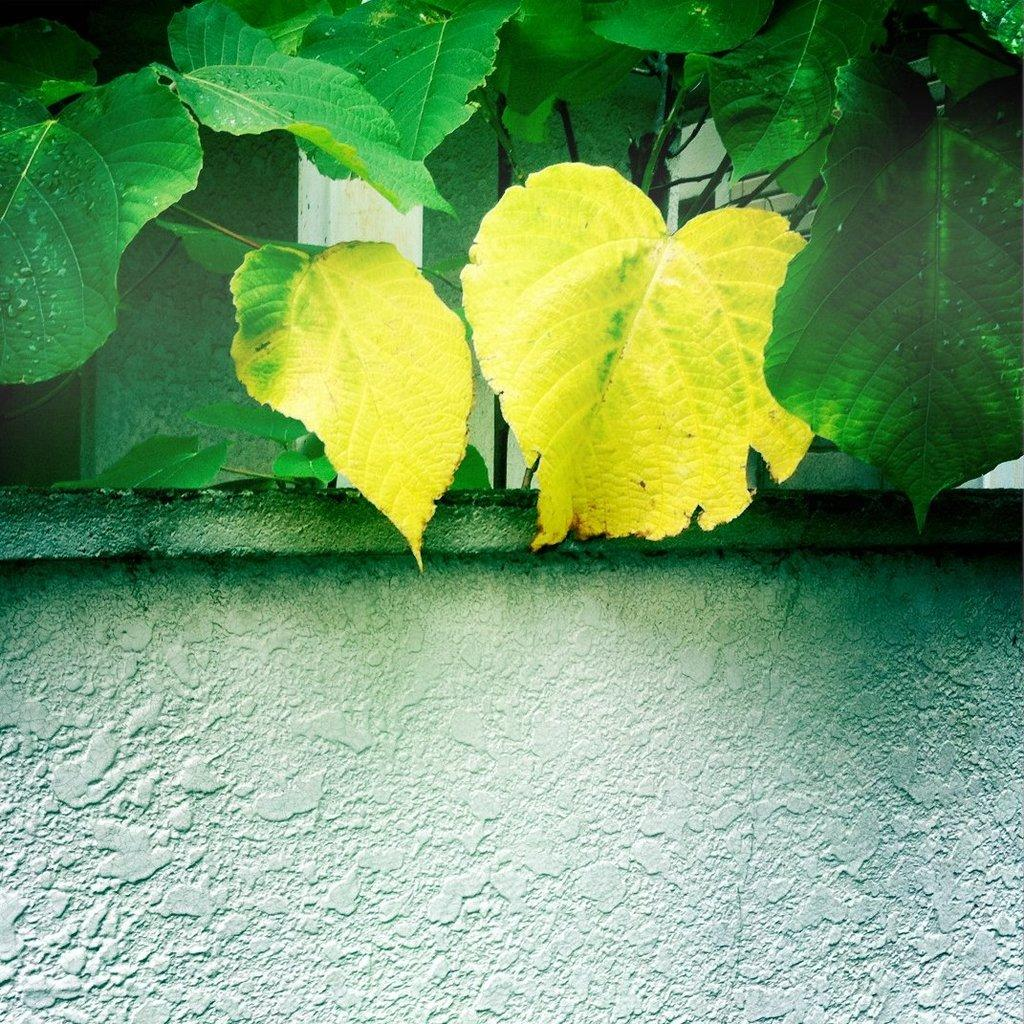What is present in the image that serves as a barrier or divider? There is a wall in the image. What type of living organisms can be seen in the image? Plants can be seen in the image. How many wings can be seen in the image? There is no wing or band present in the image. 